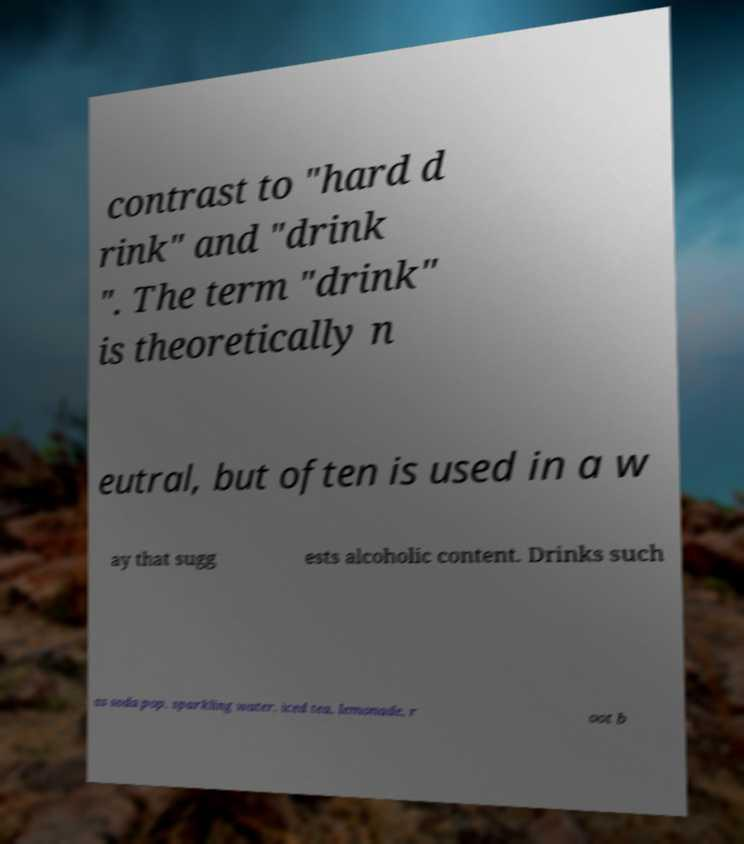What messages or text are displayed in this image? I need them in a readable, typed format. contrast to "hard d rink" and "drink ". The term "drink" is theoretically n eutral, but often is used in a w ay that sugg ests alcoholic content. Drinks such as soda pop, sparkling water, iced tea, lemonade, r oot b 